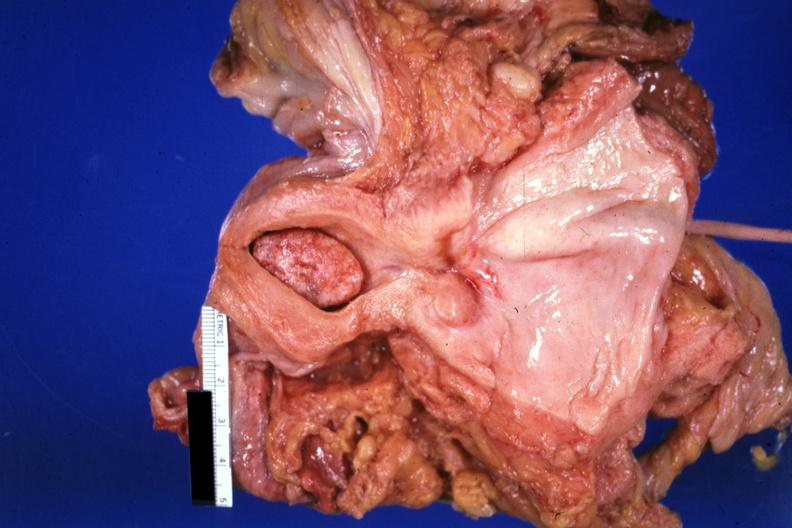s uterus present?
Answer the question using a single word or phrase. Yes 